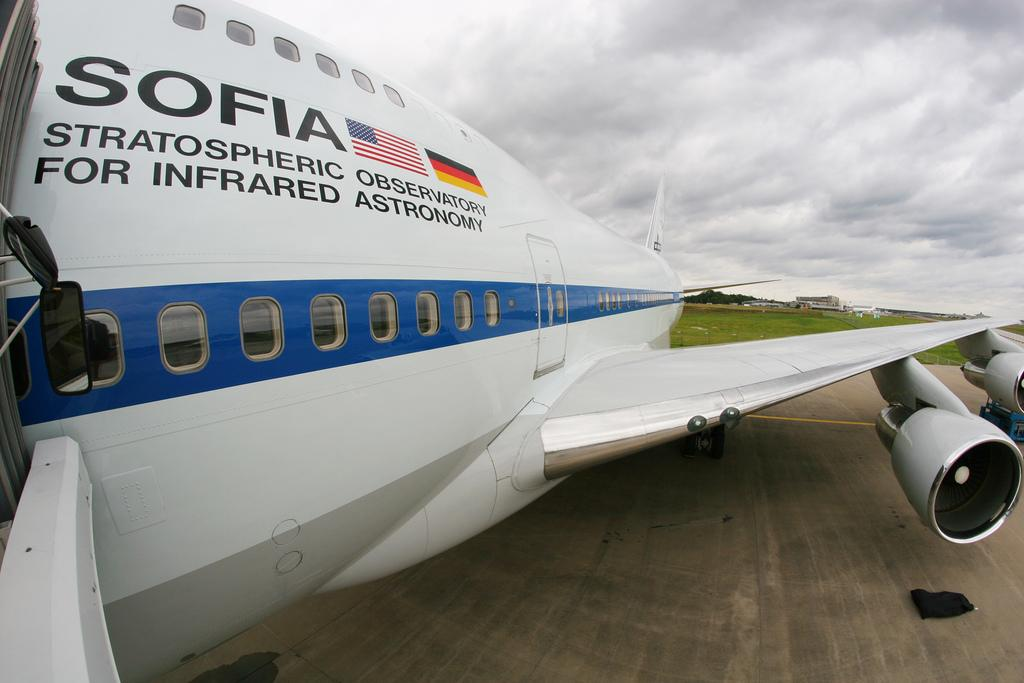Provide a one-sentence caption for the provided image. The jet clearly stated it's use for SOFIA, Stratospheric Observatory For Infrared Astronomy. 